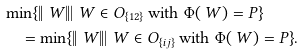Convert formula to latex. <formula><loc_0><loc_0><loc_500><loc_500>& \min \{ \| \ W \| | \ W \in O _ { \{ 1 2 \} } \text { with } \Phi ( \ W ) = P \} \\ & \quad = \min \{ \| \ W \| | \ W \in O _ { \{ i j \} } \text { with } \Phi ( \ W ) = P \} .</formula> 